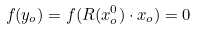<formula> <loc_0><loc_0><loc_500><loc_500>f ( { y } _ { o } ) = f ( R ( x ^ { 0 } _ { o } ) \cdot { x } _ { o } ) = 0</formula> 